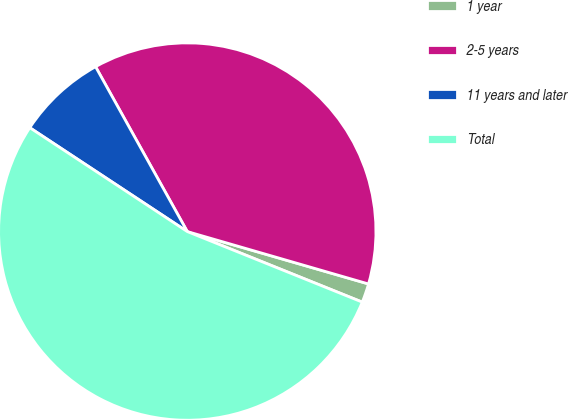Convert chart to OTSL. <chart><loc_0><loc_0><loc_500><loc_500><pie_chart><fcel>1 year<fcel>2-5 years<fcel>11 years and later<fcel>Total<nl><fcel>1.62%<fcel>37.56%<fcel>7.64%<fcel>53.18%<nl></chart> 